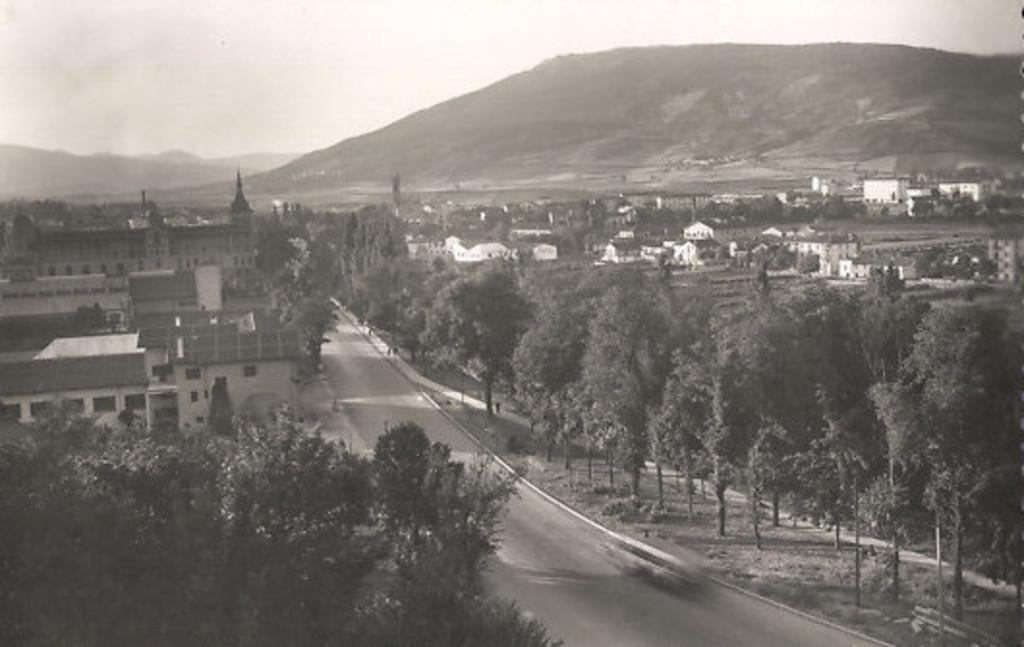What type of structures can be seen in the image? There are buildings in the image. What natural elements are present in the image? There are trees and hills in the image. What type of vegetation can be seen in the image? There are plants in the image. What man-made feature is visible in the image? There is a road in the image. What part of the natural environment is visible in the image? The sky is visible in the image. What type of quilt is being used to cover the wilderness in the image? There is no quilt present in the image, nor is there any wilderness depicted. How many houses are visible in the image? The image does not show any houses; it only features buildings, trees, hills, plants, a road, and the sky. 